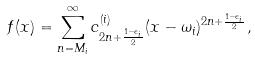Convert formula to latex. <formula><loc_0><loc_0><loc_500><loc_500>f ( x ) = \sum _ { n = M _ { i } } ^ { \infty } c ^ { ( i ) } _ { 2 n + \frac { 1 - \epsilon _ { i } } { 2 } } ( x - \omega _ { i } ) ^ { 2 n + \frac { 1 - \epsilon _ { i } } { 2 } } ,</formula> 